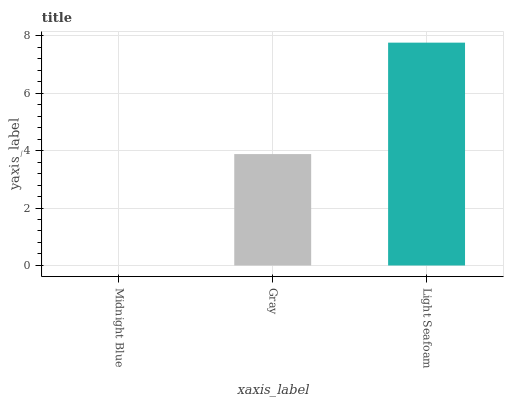Is Midnight Blue the minimum?
Answer yes or no. Yes. Is Light Seafoam the maximum?
Answer yes or no. Yes. Is Gray the minimum?
Answer yes or no. No. Is Gray the maximum?
Answer yes or no. No. Is Gray greater than Midnight Blue?
Answer yes or no. Yes. Is Midnight Blue less than Gray?
Answer yes or no. Yes. Is Midnight Blue greater than Gray?
Answer yes or no. No. Is Gray less than Midnight Blue?
Answer yes or no. No. Is Gray the high median?
Answer yes or no. Yes. Is Gray the low median?
Answer yes or no. Yes. Is Midnight Blue the high median?
Answer yes or no. No. Is Midnight Blue the low median?
Answer yes or no. No. 